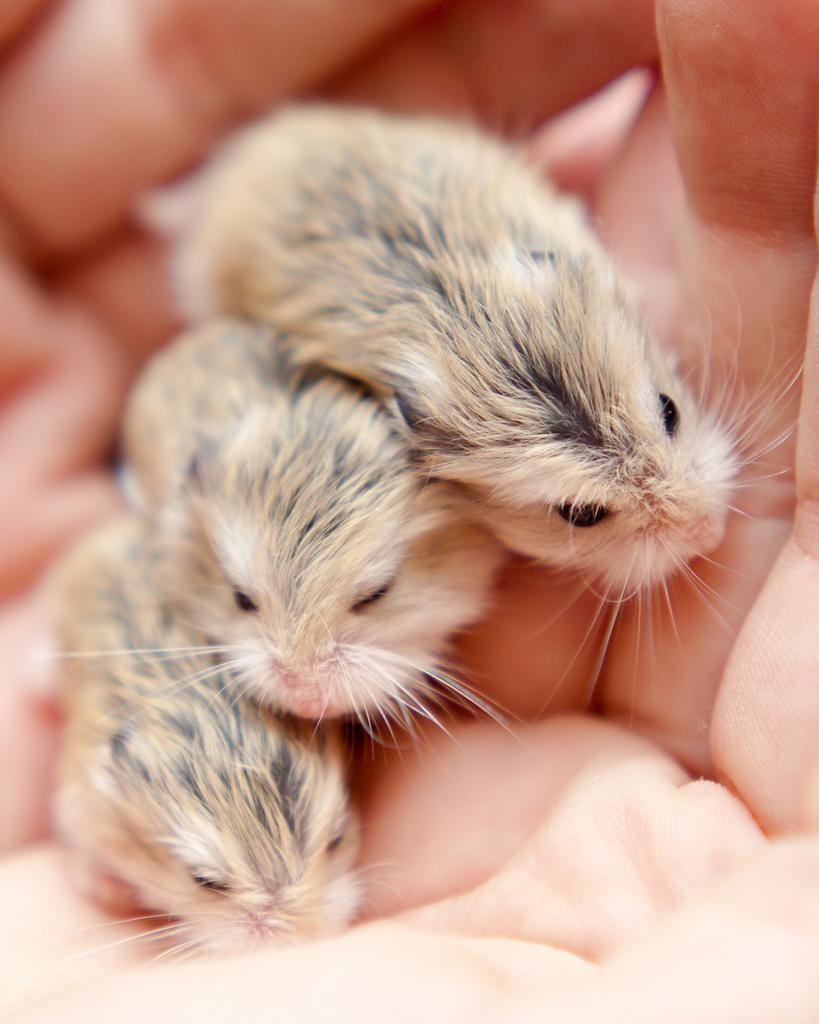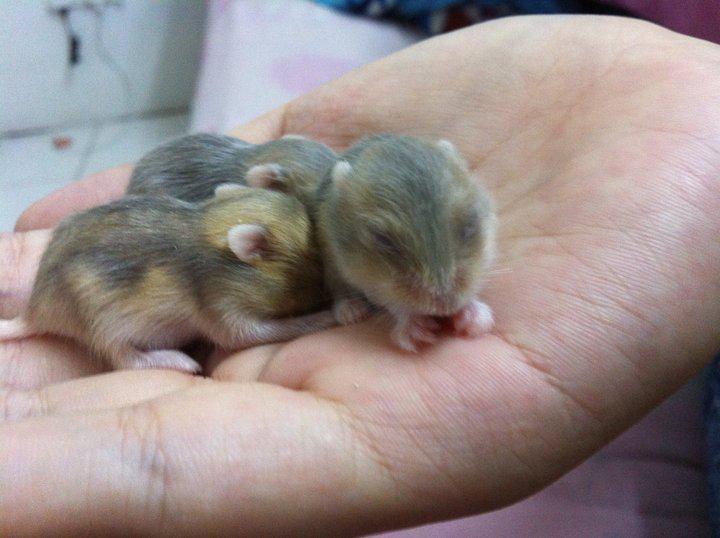The first image is the image on the left, the second image is the image on the right. Analyze the images presented: Is the assertion "In each image, one hand is palm up holding one pet rodent." valid? Answer yes or no. No. 